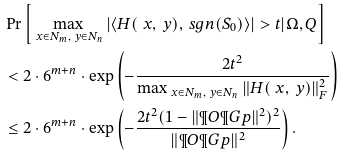Convert formula to latex. <formula><loc_0><loc_0><loc_500><loc_500>& \Pr \left [ \max _ { \ x \in N _ { m } , \ y \in N _ { n } } \left | \left \langle H ( \ x , \ y ) , \ s g n ( S _ { 0 } ) \right \rangle \right | > t | \Omega , Q \right ] \\ & < 2 \cdot 6 ^ { m + n } \cdot \exp \left ( - \frac { 2 t ^ { 2 } } { \max _ { \ x \in N _ { m } , \ y \in N _ { n } } \| H ( \ x , \ y ) \| _ { F } ^ { 2 } } \right ) \\ & \leq 2 \cdot 6 ^ { m + n } \cdot \exp \left ( - \frac { 2 t ^ { 2 } ( 1 - \| \P O \P G p \| ^ { 2 } ) ^ { 2 } } { \| \P O \P G p \| ^ { 2 } } \right ) .</formula> 